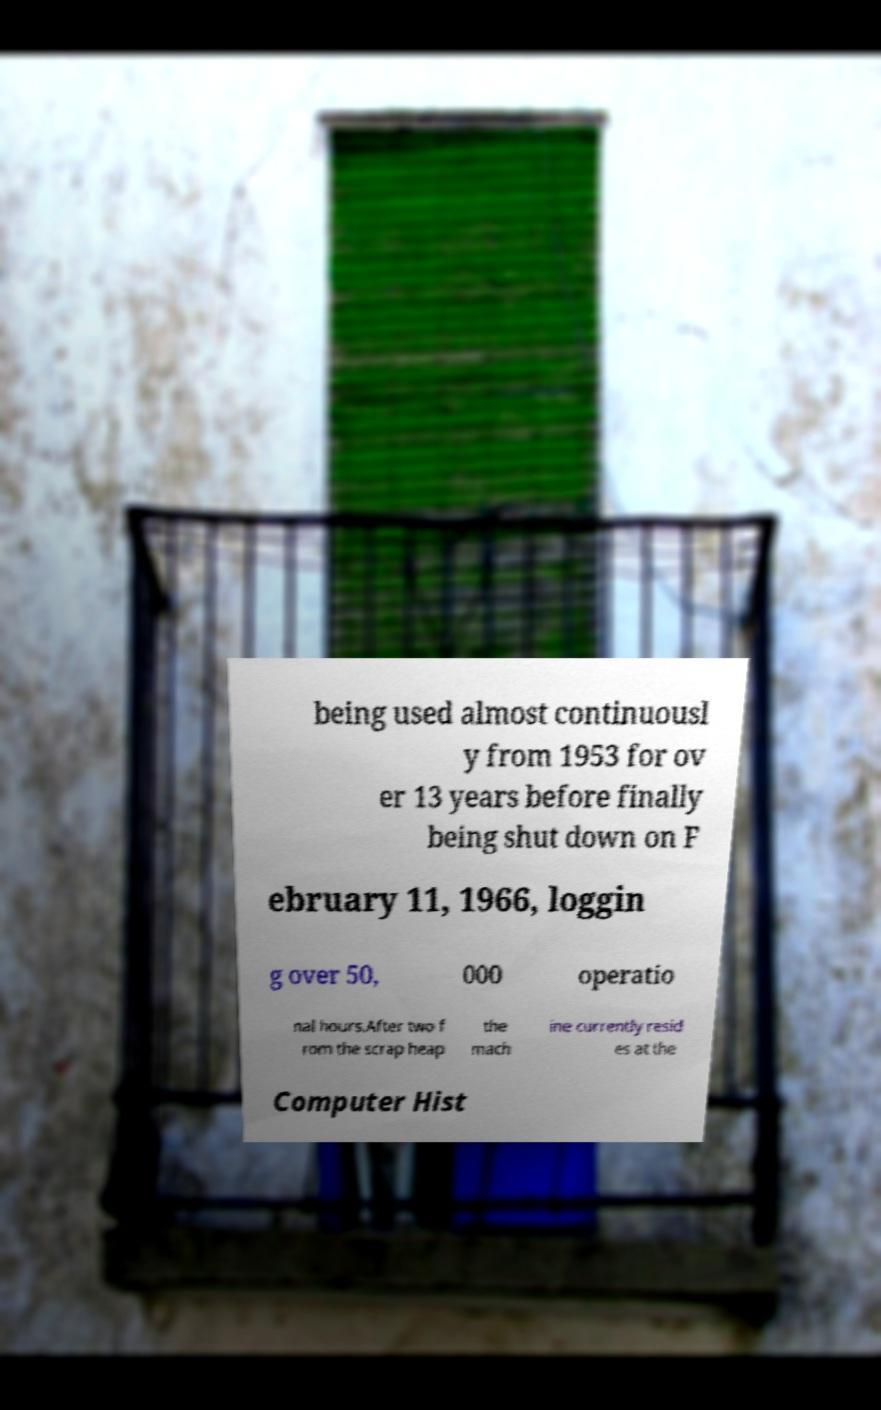Can you accurately transcribe the text from the provided image for me? being used almost continuousl y from 1953 for ov er 13 years before finally being shut down on F ebruary 11, 1966, loggin g over 50, 000 operatio nal hours.After two f rom the scrap heap the mach ine currently resid es at the Computer Hist 